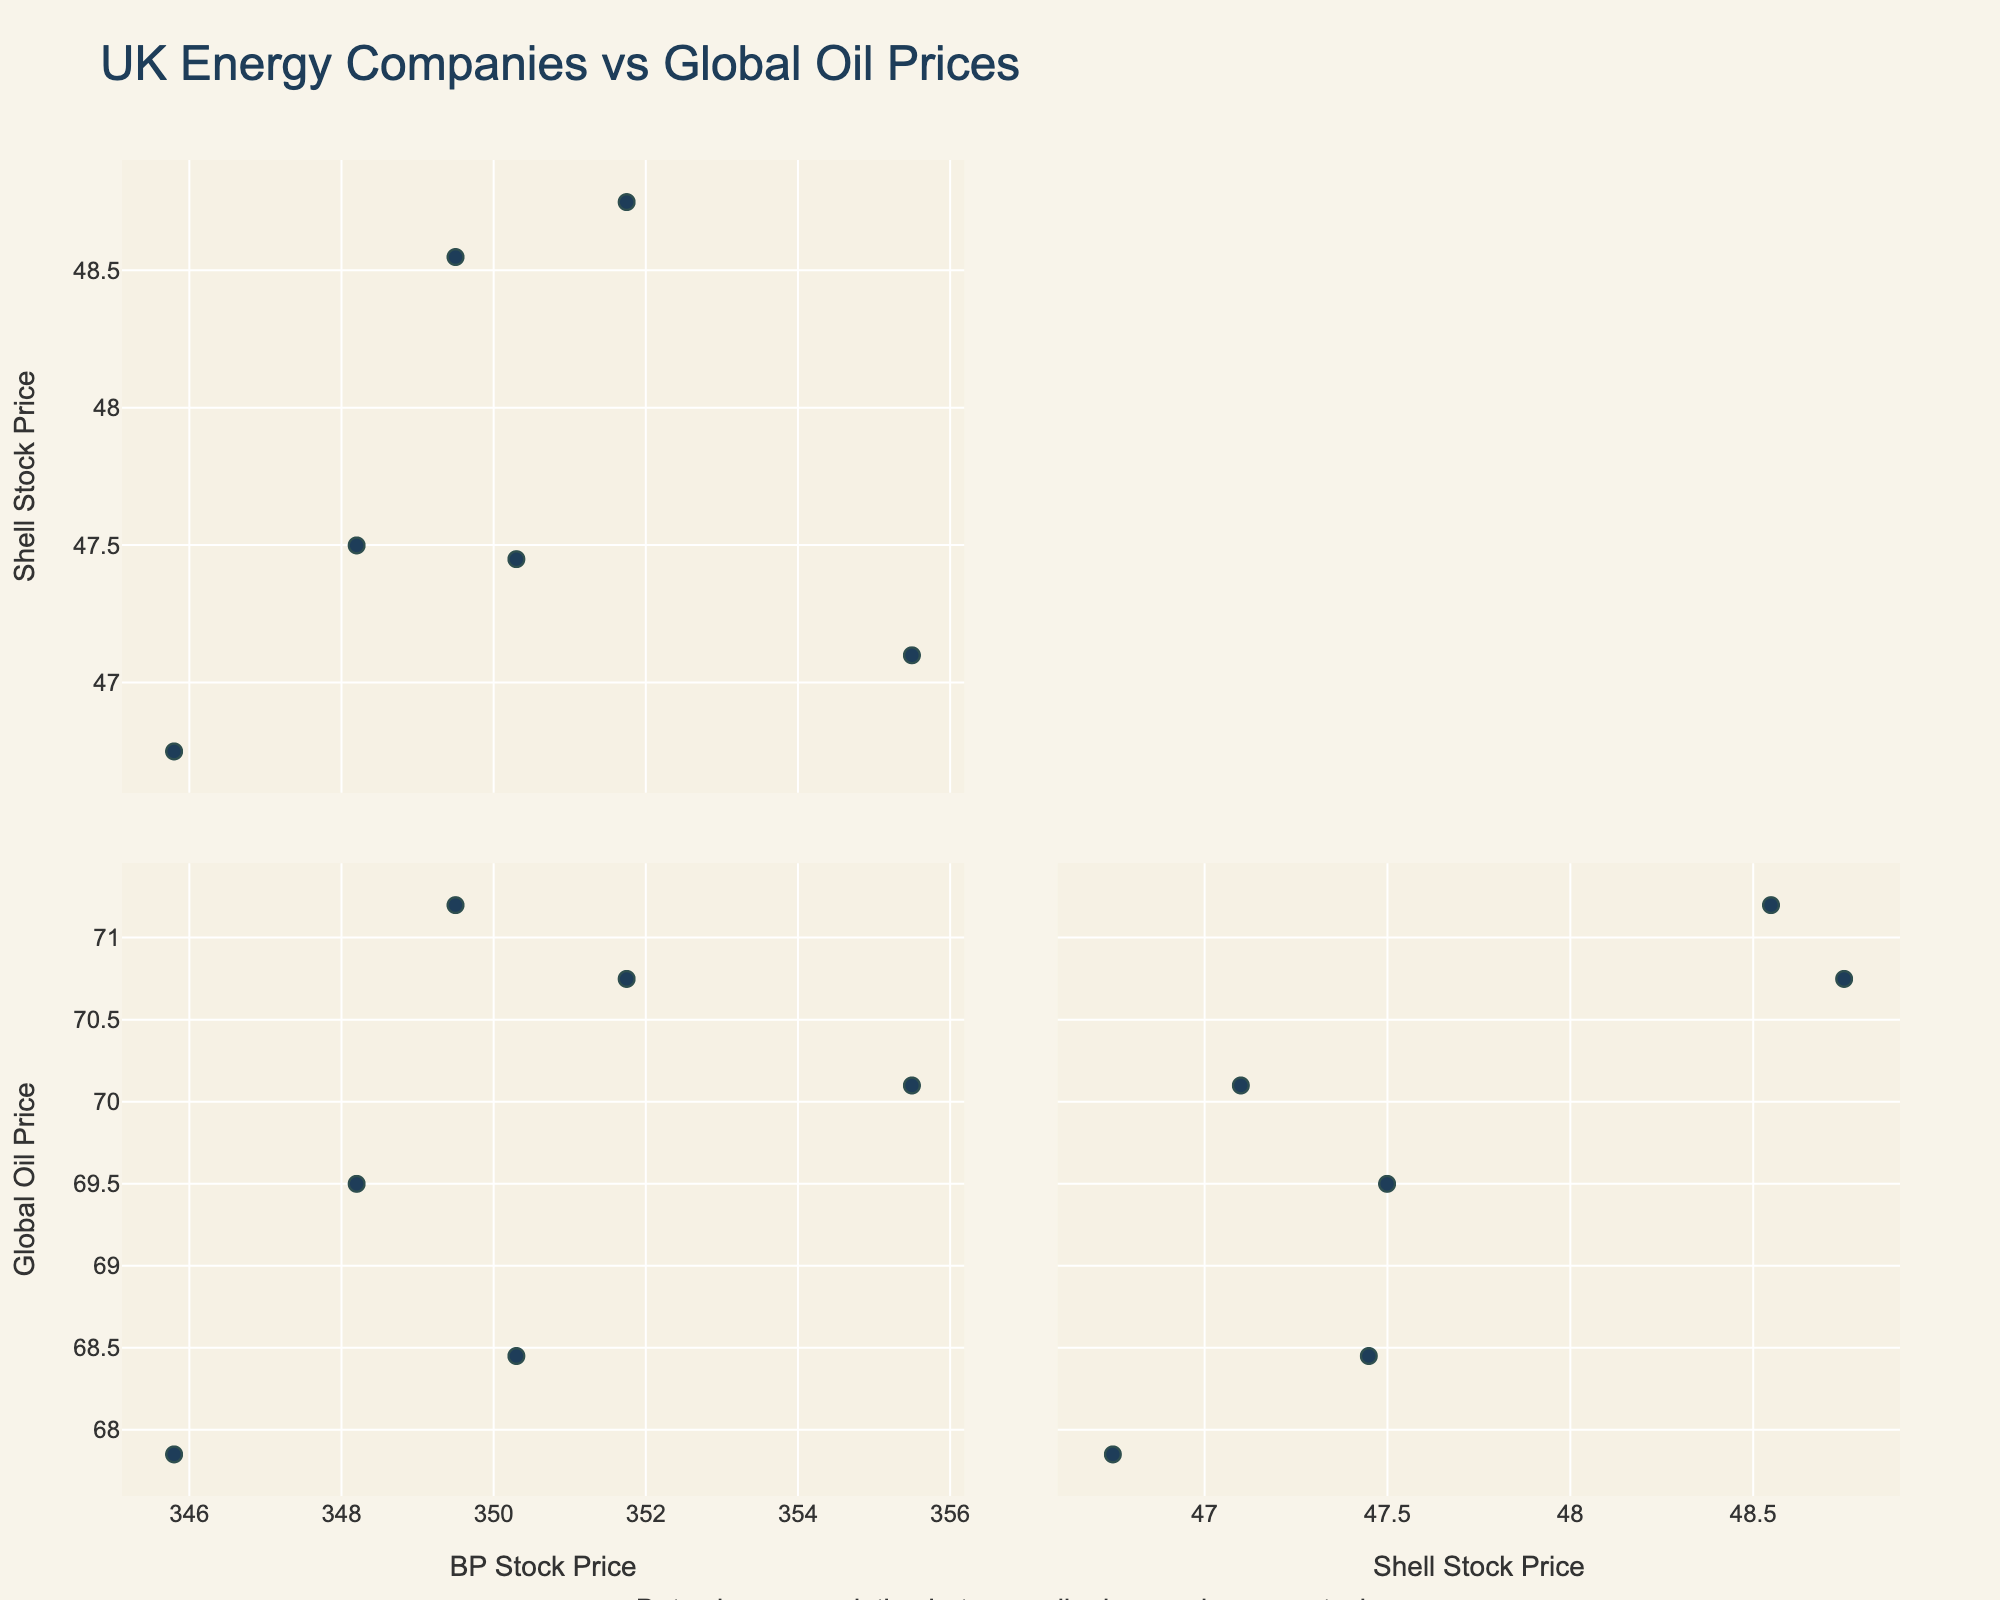What's the title of the scatter plot matrix? The title is shown at the top of the figure and helps to identify the main subject of the plot. In this case, it is "UK Energy Companies vs Global Oil Prices".
Answer: UK Energy Companies vs Global Oil Prices What are the labels for the axes? The axis labels are given to identify what each axis represents. The labels here are "BP Stock Price", "Shell Stock Price", and "Global Oil Price".
Answer: BP Stock Price, Shell Stock Price, Global Oil Price How many different companies are represented in the scatter plots? Each scatter plot matrix cell represents a comparison between certain company stock prices and global oil prices. The companies involved are BP and Shell.
Answer: 2 (BP and Shell) Is there a visible correlation between BP stock prices and global oil prices? To determine correlation, we look for a trend in the scatter plot between "BP Stock Price" and "Global Oil Price". If the points form a line or an upward/downward trend, there is a correlation.
Answer: Yes, there is a visible correlation Which stock price seems to have the highest variability when compared to global oil prices? Variability can be observed by the spread of data points in the scatter plot matrix. The stock price with a wider spread relative to the line indicates higher variability. Compare "BP Stock Price" and "Shell Stock Price" plots against "Global Oil Price".
Answer: BP stock price Does Shell's stock price show a strong correlation with BP's stock price? Look at the scatter plot cell comparing "BP Stock Price" and "Shell Stock Price". If points form a clear line or trend, there is a strong correlation, otherwise not.
Answer: Not very strong On average, does the BP stock price increase or decrease with rising global oil prices? Observe the trend direction in the scatter plot comparing "BP Stock Price" with "Global Oil Price". If points rise from left to right, it increases; if they fall, it decreases.
Answer: Increase Based on the scatter plot matrix, on which axis (dimension) is the least variability observed? Least variability implies data points clustering closely along a dimension. Analyze which scatter plot (with dimensions on the axes) shows the most compact cluster of points.
Answer: Shell Stock Price vs Global Oil Price How does the scatter plot matrix help in visualizing relationships between variables? The scatter plot matrix compares all pairs of variables, allowing us to see potential correlations and patterns across multiple dimensions. Each cell shows a scatter plot of two variables with their correlations visible.
Answer: It shows pairwise relationships and correlations What additional annotation is provided on the scatter plot matrix? Look for any text or notes added to the plot that provides further insights or explanations. There is an annotation below the scatter plot matrix that states, "Data shows correlation between oil prices and energy stocks".
Answer: Data shows correlation between oil prices and energy stocks 